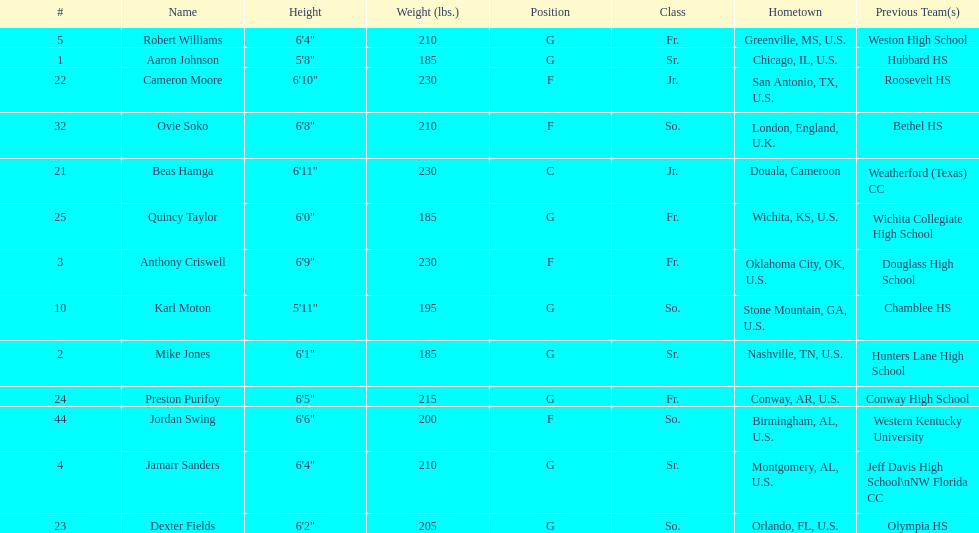Can you tell me the total seniors present in the team? 3. 